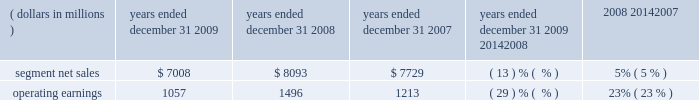Management 2019s discussion and analysis of financial condition and results of operations in 2008 , sales to the segment 2019s top five customers represented approximately 45% ( 45 % ) of the segment 2019s net sales .
The segment 2019s backlog was $ 2.3 billion at december 31 , 2008 , compared to $ 2.6 billion at december 31 , 2007 .
In 2008 , our digital video customers significantly increased their purchases of the segment 2019s products and services , primarily due to increased demand for digital entertainment devices , particularly ip and hd/dvr devices .
In february 2008 , the segment acquired the assets related to digital cable set-top products of zhejiang dahua digital technology co. , ltd and hangzhou image silicon ( known collectively as dahua digital ) , a developer , manufacturer and marketer of cable set-tops and related low-cost integrated circuits for the emerging chinese cable business .
The acquisition helped the segment strengthen its position in the rapidly growing cable market in china .
Enterprise mobility solutions segment the enterprise mobility solutions segment designs , manufactures , sells , installs and services analog and digital two-way radios , wireless lan and security products , voice and data communications products and systems for private networks , wireless broadband systems and end-to-end enterprise mobility solutions to a wide range of customers , including government and public safety agencies ( which , together with all sales to distributors of two-way communication products , are referred to as the 2018 2018government and public safety market 2019 2019 ) , as well as retail , energy and utilities , transportation , manufacturing , healthcare and other commercial customers ( which , collectively , are referred to as the 2018 2018commercial enterprise market 2019 2019 ) .
In 2009 , the segment 2019s net sales represented 32% ( 32 % ) of the company 2019s consolidated net sales , compared to 27% ( 27 % ) in 2008 and 21% ( 21 % ) in 2007 .
Years ended december 31 percent change ( dollars in millions ) 2009 2008 2007 2009 20142008 2008 20142007 .
Segment results 20142009 compared to 2008 in 2009 , the segment 2019s net sales were $ 7.0 billion , a decrease of 13% ( 13 % ) compared to net sales of $ 8.1 billion in 2008 .
The 13% ( 13 % ) decrease in net sales reflects a 21% ( 21 % ) decrease in net sales to the commercial enterprise market and a 10% ( 10 % ) decrease in net sales to the government and public safety market .
The decrease in net sales to the commercial enterprise market reflects decreased net sales in all regions .
The decrease in net sales to the government and public safety market was primarily driven by decreased net sales in emea , north america and latin america , partially offset by higher net sales in asia .
The segment 2019s overall net sales were lower in north america , emea and latin america and higher in asia the segment had operating earnings of $ 1.1 billion in 2009 , a decrease of 29% ( 29 % ) compared to operating earnings of $ 1.5 billion in 2008 .
The decrease in operating earnings was primarily due to a decrease in gross margin , driven by the 13% ( 13 % ) decrease in net sales and an unfavorable product mix .
Also contributing to the decrease in operating earnings was an increase in reorganization of business charges , relating primarily to higher employee severance costs .
These factors were partially offset by decreased sg&a expenses and r&d expenditures , primarily related to savings from cost-reduction initiatives .
As a percentage of net sales in 2009 as compared 2008 , gross margin decreased and r&d expenditures and sg&a expenses increased .
Net sales in north america continued to comprise a significant portion of the segment 2019s business , accounting for approximately 58% ( 58 % ) of the segment 2019s net sales in 2009 , compared to approximately 57% ( 57 % ) in 2008 .
The regional shift in 2009 as compared to 2008 reflects a 16% ( 16 % ) decline in net sales outside of north america and a 12% ( 12 % ) decline in net sales in north america .
The segment 2019s backlog was $ 2.4 billion at both december 31 , 2009 and december 31 , 2008 .
In our government and public safety market , we see a continued emphasis on mission-critical communication and homeland security solutions .
In 2009 , we led market innovation through the continued success of our mototrbo line and the delivery of the apx fffd family of products .
While spending by end customers in the segment 2019s government and public safety market is affected by government budgets at the national , state and local levels , we continue to see demand for large-scale mission critical communications systems .
In 2009 , we had significant wins across the globe , including several city and statewide communications systems in the united states , and continued success winning competitive projects with our tetra systems in europe , the middle east .
How many sales did the north america account for in 2009? 
Rationale: $ 3994.6 , the percentage of north american sales was given in line 18 . we take that percentage and multiple by the segmented net sales to get our answer .
Computations: (7008 * 57%)
Answer: 3994.56. 